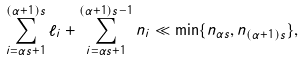Convert formula to latex. <formula><loc_0><loc_0><loc_500><loc_500>\sum _ { i = \alpha s + 1 } ^ { ( \alpha + 1 ) s } \ell _ { i } + \sum _ { i = \alpha s + 1 } ^ { ( \alpha + 1 ) s - 1 } n _ { i } \ll \min \{ n _ { \alpha s } , n _ { ( \alpha + 1 ) s } \} ,</formula> 